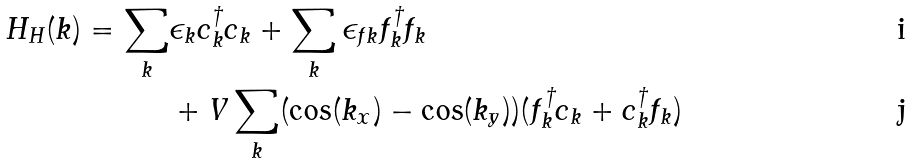Convert formula to latex. <formula><loc_0><loc_0><loc_500><loc_500>H _ { H } ( k ) = \sum _ { k } & \epsilon _ { k } c ^ { \dag } _ { k } c _ { k } + \sum _ { k } \epsilon _ { f k } f ^ { \dag } _ { k } f _ { k } \\ & + V \sum _ { k } ( \cos ( k _ { x } ) - \cos ( k _ { y } ) ) ( f ^ { \dag } _ { k } c _ { k } + c ^ { \dag } _ { k } f _ { k } )</formula> 